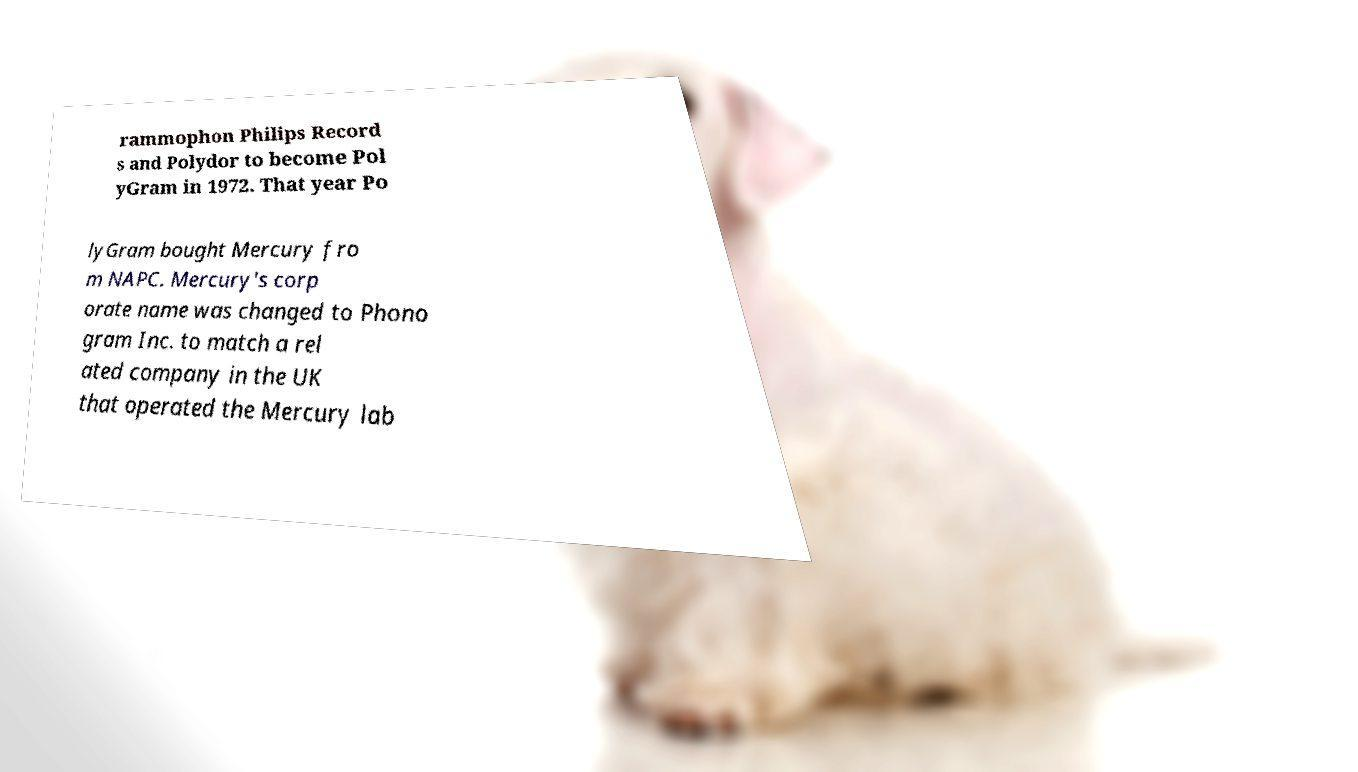For documentation purposes, I need the text within this image transcribed. Could you provide that? rammophon Philips Record s and Polydor to become Pol yGram in 1972. That year Po lyGram bought Mercury fro m NAPC. Mercury's corp orate name was changed to Phono gram Inc. to match a rel ated company in the UK that operated the Mercury lab 